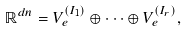<formula> <loc_0><loc_0><loc_500><loc_500>\mathbb { R } ^ { d n } = V _ { e } ^ { ( I _ { 1 } ) } \oplus \dots \oplus V _ { e } ^ { ( I _ { r } ) } ,</formula> 